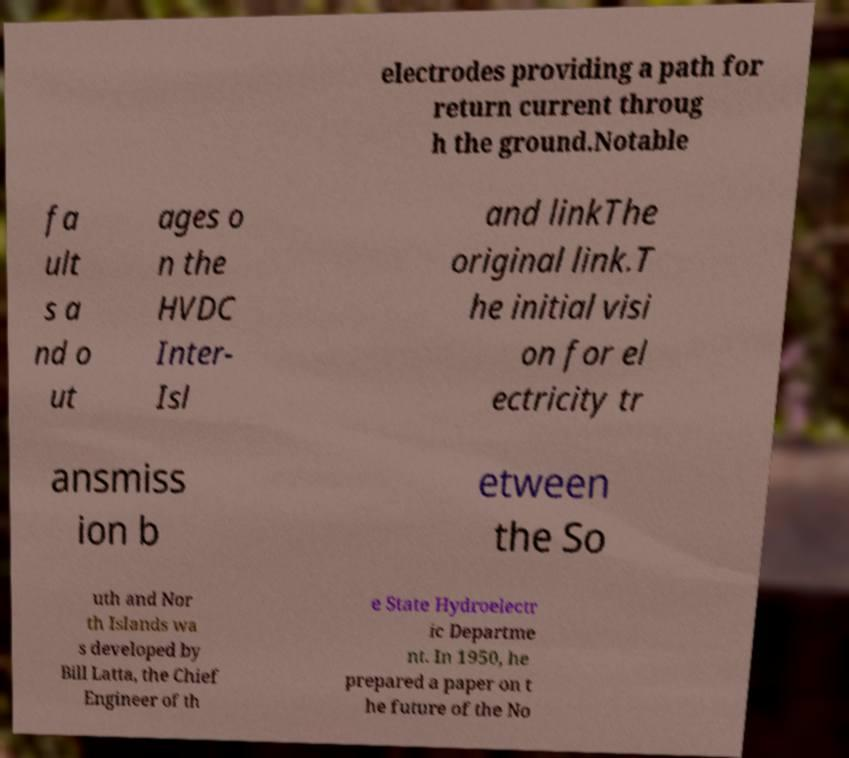Can you accurately transcribe the text from the provided image for me? electrodes providing a path for return current throug h the ground.Notable fa ult s a nd o ut ages o n the HVDC Inter- Isl and linkThe original link.T he initial visi on for el ectricity tr ansmiss ion b etween the So uth and Nor th Islands wa s developed by Bill Latta, the Chief Engineer of th e State Hydroelectr ic Departme nt. In 1950, he prepared a paper on t he future of the No 